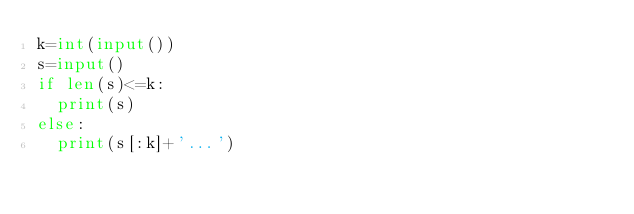Convert code to text. <code><loc_0><loc_0><loc_500><loc_500><_Python_>k=int(input())
s=input()
if len(s)<=k:
  print(s)
else:
  print(s[:k]+'...')</code> 